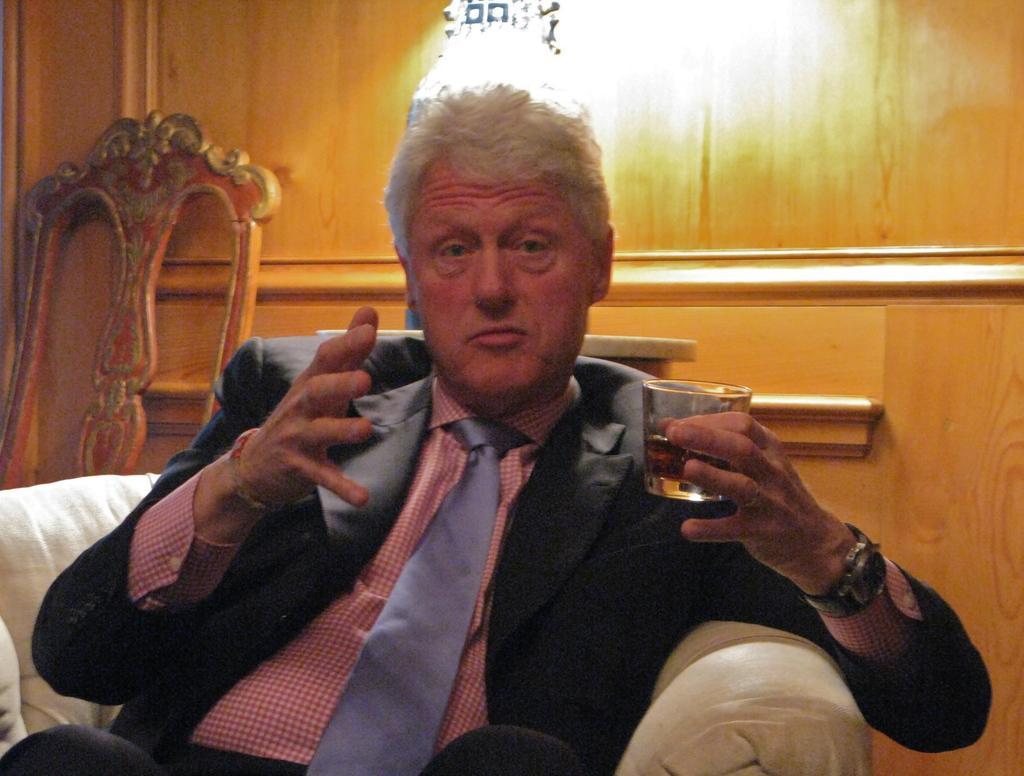How would you summarize this image in a sentence or two? This is a picture of a man who is sitting on a chair there is other chair that is wood the person is holding a wine glass to the hand he is having a watch also and the background of the person is a wall which is in wooden color and the top of his head there is a light. 